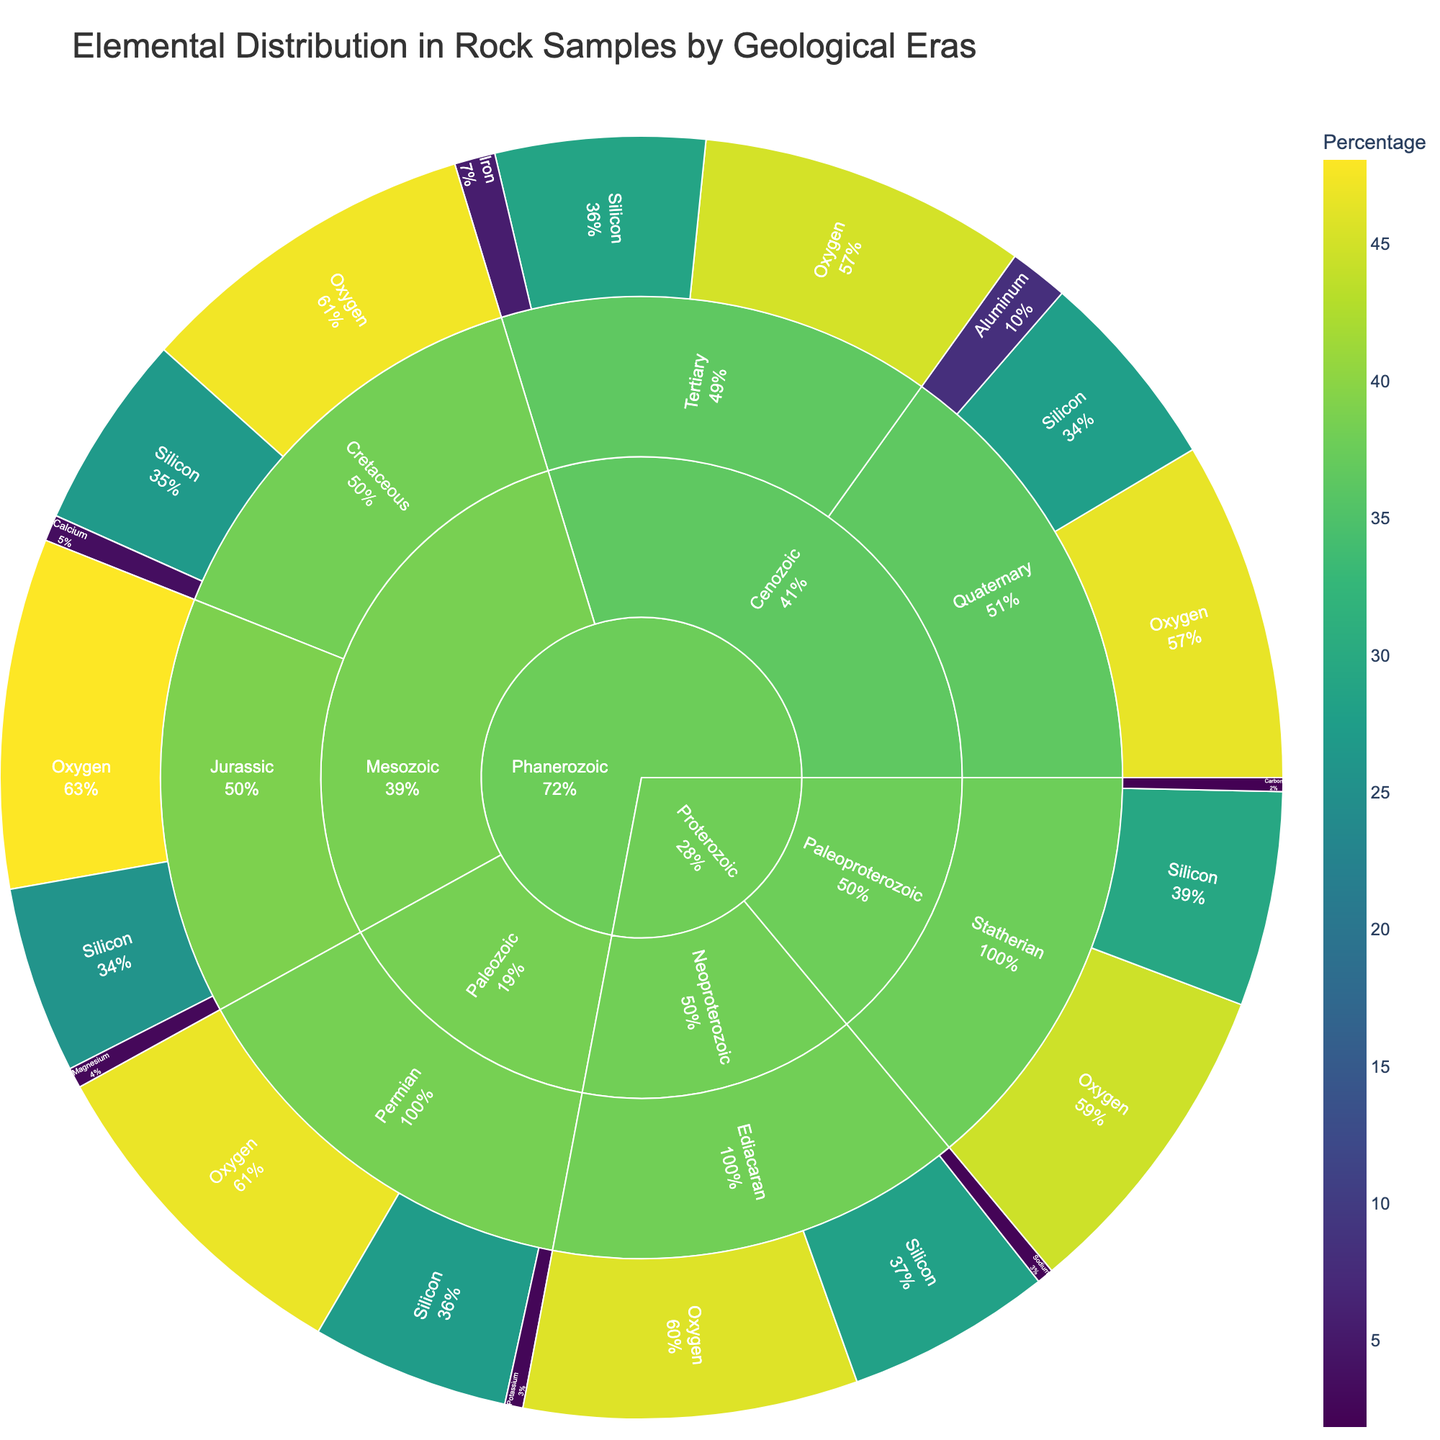What is the title of the sunburst plot? The title is displayed at the top of the plot and it provides a summary of what the plot represents. Here, it mentions the elemental distribution in rock samples by geological eras.
Answer: Elemental Distribution in Rock Samples by Geological Eras Which epoch within the Paleozoic era has data in the plot? In the sunburst plot, you can navigate from the era to the periods and then to the epochs within those periods. Within the Paleozoic era, specifically, the epoch shown is the Permian epoch.
Answer: Permian What is the percentage of Silicon in the Mesozoic, Jurassic epoch? Navigate from Mesozoic era to Jurassic epoch in the sunburst plot, then look for Silicon. The percentage is shown directly adjacent.
Answer: 25.7% Compare the Oxygen percentages between the Cenozoic, Quaternary epoch and the Mesozoic, Cretaceous epoch. Which one is higher and by how much? First find the Oxygen percentages in both epochs. For Cenozoic, Quaternary, the percentage is 46.6%, and for Mesozoic, Cretaceous, it is 47.3%. Subtract 46.6% from 47.3% to compare the two values.
Answer: Mesozoic, Cretaceous is higher by 0.7% How does the percentage of Aluminum in the Cenozoic, Quaternary epoch compare to Iron in the Cenozoic, Tertiary epoch? Find the values for both Aluminum and Iron in the specified epochs. For Aluminum in Cenozoic, Quaternary, it is 8.1%, and for Iron in Cenozoic, Tertiary, it is 5.6%. Compare these two values directly.
Answer: Aluminum in Quaternary is higher than Iron in Tertiary by 2.5% What is the median percentage of Silicon across all epochs? List the percentages of Silicon across all epochs: 27.7%, 28.8%, 26.9%, 25.7%, 27.2%, 28.2%, 29.5%. Next, sort these values: 25.7%, 26.9%, 27.2%, 27.7%, 28.2%, 28.8%, 29.5%. The median is the middle value in this sorted list.
Answer: 27.7% Which element in the Proterozoic, Paleoproterozoic, Statherian epoch has the highest percentage? Navigate from Proterozoic to Paleoproterozoic period, then to Statherian epoch. Compare the percentages of elements listed within this epoch. Oxygen has 44.7%, Silicon has 29.5%, and Carbon has 1.9%.
Answer: Silicon How many elements are represented in the Phanerozoic, Mesozoic, Jurassic epoch? Locate the Jurassic epoch within the Mesozoic period under the Phanerozoic era. Count the number of elements listed within that epoch. There are three elements: Oxygen, Silicon, and Magnesium.
Answer: 3 Is the percentage of Oxygen in the Cenozoic, Quaternary epoch greater than or less than the percentage of Oxygen in the Neoproterozoic, Ediacaran epoch? Find the Oxygen percentages in both epochs. For Cenozoic, Quaternary, it is 46.6%, and for Neoproterozoic, Ediacaran, it is 45.9%. Compare these two values directly.
Answer: Greater Among all epochs within the Cenozoic period, which element has the largest percentage difference when comparing its two epochs? Compare each element's percentage in both epochs. For example, Oxygen: 46.6% (Quaternary) vs. 45.2% (Tertiary). Silicon: 27.7% (Quaternary) vs. 28.8% (Tertiary). Iron is only in Tertiary. Compare the differences and find the largest one.
Answer: Silicon (1.1%) 